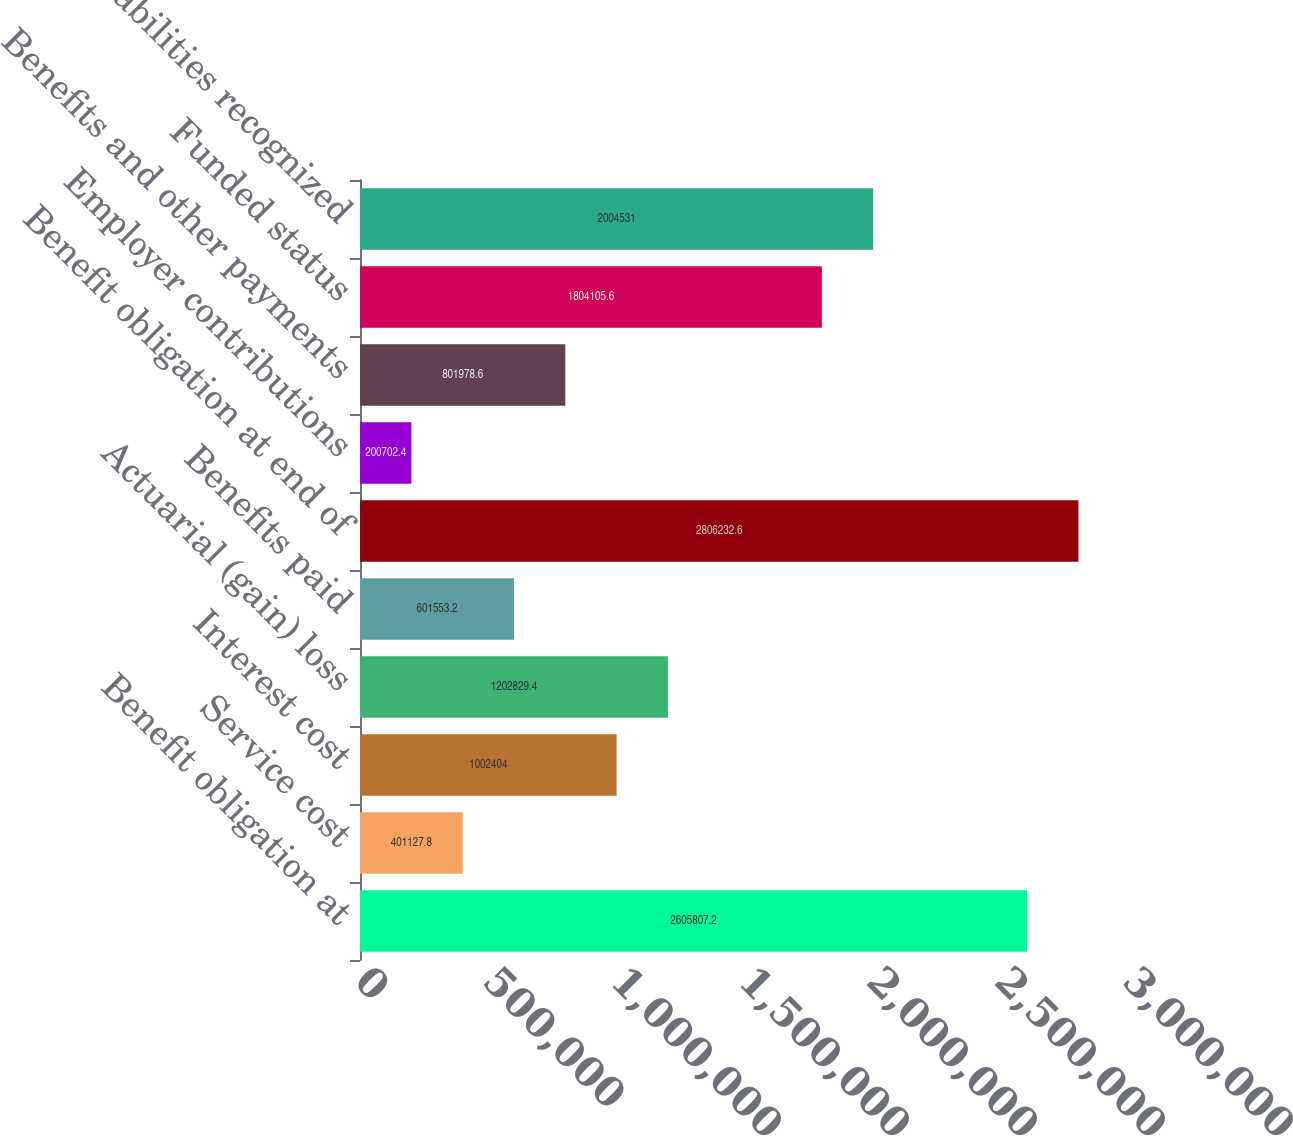<chart> <loc_0><loc_0><loc_500><loc_500><bar_chart><fcel>Benefit obligation at<fcel>Service cost<fcel>Interest cost<fcel>Actuarial (gain) loss<fcel>Benefits paid<fcel>Benefit obligation at end of<fcel>Employer contributions<fcel>Benefits and other payments<fcel>Funded status<fcel>Accrued liabilities recognized<nl><fcel>2.60581e+06<fcel>401128<fcel>1.0024e+06<fcel>1.20283e+06<fcel>601553<fcel>2.80623e+06<fcel>200702<fcel>801979<fcel>1.80411e+06<fcel>2.00453e+06<nl></chart> 